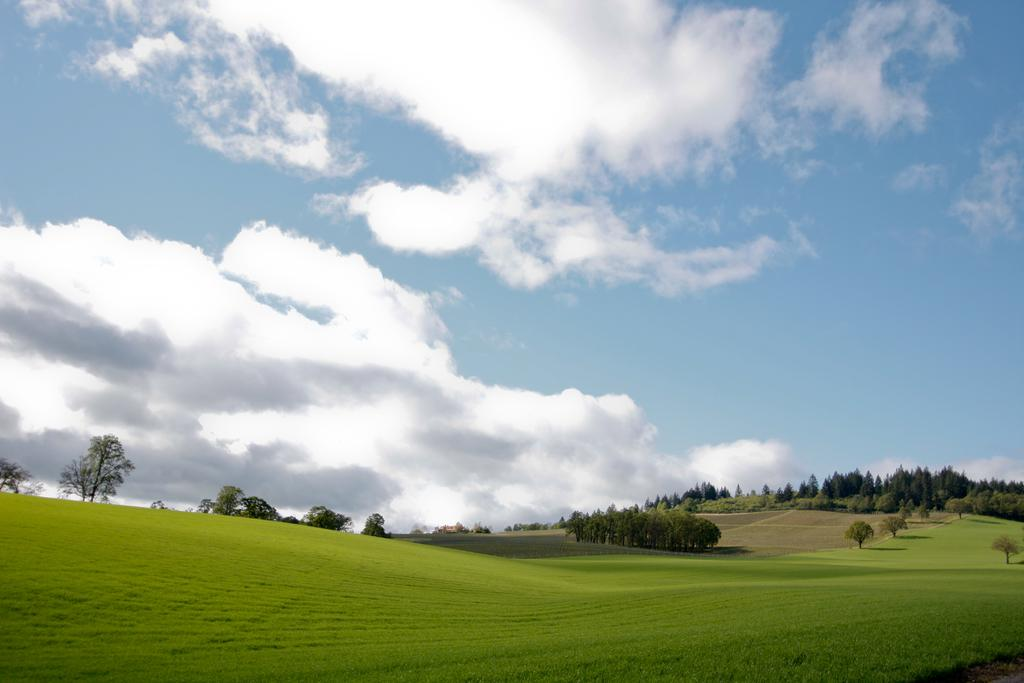What type of vegetation is present at the bottom of the image? There is grass on the ground at the bottom of the image. What can be seen in the background of the image? There are trees and clouds in the sky in the background of the image. Where are the trees located in relation to the ground? The trees are on the ground in the image. What type of tin can be seen in the image? There is no tin present in the image. What observation can be made about the clouds in the image? The clouds are visible in the sky in the background of the image, but no specific observation about their appearance or behavior is mentioned in the facts. 